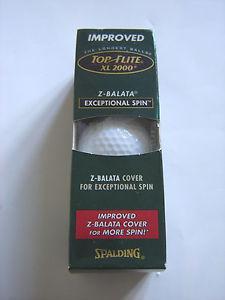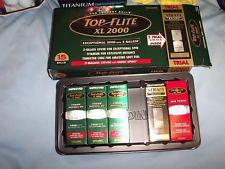The first image is the image on the left, the second image is the image on the right. Analyze the images presented: Is the assertion "All of the golf balls are inside boxes." valid? Answer yes or no. Yes. The first image is the image on the left, the second image is the image on the right. Examine the images to the left and right. Is the description "An image includes at least one golf ball out of its package, next to a box made to hold a few balls." accurate? Answer yes or no. No. 